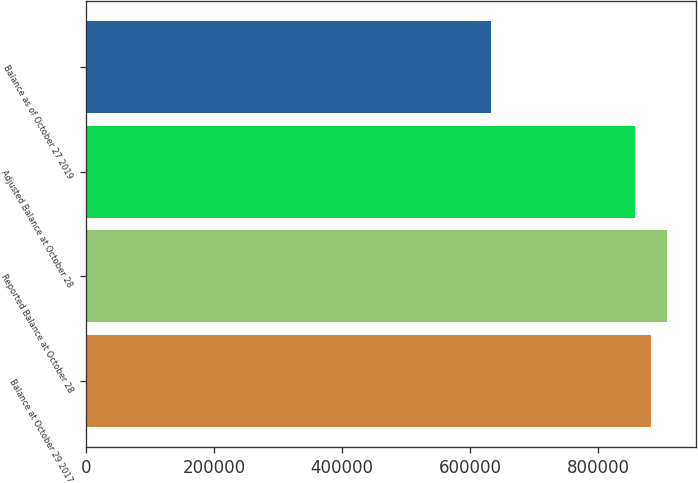<chart> <loc_0><loc_0><loc_500><loc_500><bar_chart><fcel>Balance at October 29 2017<fcel>Reported Balance at October 28<fcel>Adjusted Balance at October 28<fcel>Balance as of October 27 2019<nl><fcel>882582<fcel>907610<fcel>857373<fcel>632301<nl></chart> 